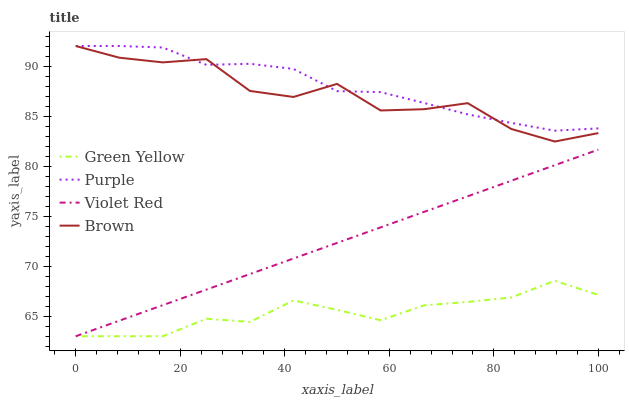Does Green Yellow have the minimum area under the curve?
Answer yes or no. Yes. Does Purple have the maximum area under the curve?
Answer yes or no. Yes. Does Brown have the minimum area under the curve?
Answer yes or no. No. Does Brown have the maximum area under the curve?
Answer yes or no. No. Is Violet Red the smoothest?
Answer yes or no. Yes. Is Brown the roughest?
Answer yes or no. Yes. Is Brown the smoothest?
Answer yes or no. No. Is Violet Red the roughest?
Answer yes or no. No. Does Violet Red have the lowest value?
Answer yes or no. Yes. Does Brown have the lowest value?
Answer yes or no. No. Does Brown have the highest value?
Answer yes or no. Yes. Does Violet Red have the highest value?
Answer yes or no. No. Is Green Yellow less than Brown?
Answer yes or no. Yes. Is Brown greater than Violet Red?
Answer yes or no. Yes. Does Purple intersect Brown?
Answer yes or no. Yes. Is Purple less than Brown?
Answer yes or no. No. Is Purple greater than Brown?
Answer yes or no. No. Does Green Yellow intersect Brown?
Answer yes or no. No. 